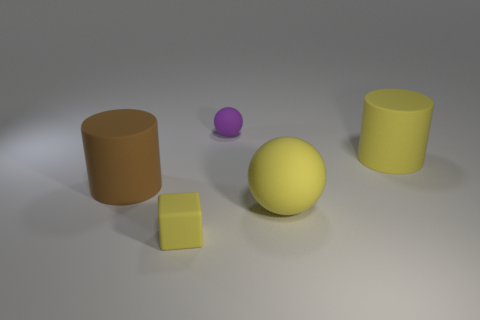The rubber block that is the same color as the big ball is what size?
Your answer should be very brief. Small. Do the large rubber ball and the tiny rubber cube have the same color?
Provide a short and direct response. Yes. Are there any blue shiny spheres that have the same size as the purple thing?
Your response must be concise. No. What size is the brown matte cylinder?
Ensure brevity in your answer.  Large. What number of other objects are the same size as the purple rubber thing?
Your answer should be compact. 1. Is the number of large things behind the tiny yellow matte object less than the number of things that are in front of the small purple thing?
Ensure brevity in your answer.  Yes. How big is the rubber cylinder left of the tiny object on the left side of the tiny matte object to the right of the yellow matte block?
Make the answer very short. Large. There is a matte object that is both behind the yellow matte sphere and on the left side of the purple object; how big is it?
Your response must be concise. Large. The big yellow thing that is on the right side of the ball to the right of the purple thing is what shape?
Offer a terse response. Cylinder. Is there anything else of the same color as the rubber cube?
Give a very brief answer. Yes. 